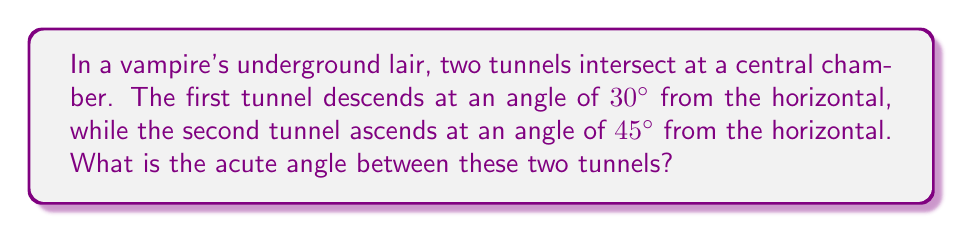Give your solution to this math problem. Let's approach this step-by-step:

1) First, we need to visualize the problem. The two tunnels can be represented as lines in a vertical plane, with the horizontal as our reference line.

2) Let's define our angles:
   - Tunnel 1 makes a 30° angle below the horizontal
   - Tunnel 2 makes a 45° angle above the horizontal

3) To find the angle between the tunnels, we need to add these two angles:
   
   $$\text{Angle between tunnels} = 30° + 45° = 75°$$

4) However, this is not the acute angle. In geometry, when we talk about the angle between lines, we usually mean the smaller of the two angles formed.

5) To find the acute angle, we need to subtract this result from 180°:

   $$\text{Acute angle} = 180° - 75° = 105°$$

6) Therefore, the acute angle between the two tunnels is 105°.

[asy]
import geometry;

size(200);
draw((-3,0)--(3,0),arrow=Arrow(TeXHead));
draw((0,-2)--(0,2),arrow=Arrow(TeXHead));

draw((-2,-1)--(2,1),red);
draw((-2,2)--(2,-2),blue);

label("30°", (-1.5,-0.5), SE, red);
label("45°", (-1.5,1.5), NW, blue);
label("105°", (0,0), E);

dot((0,0));
[/asy]
Answer: 105° 